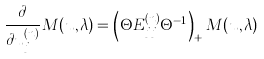Convert formula to latex. <formula><loc_0><loc_0><loc_500><loc_500>\frac { \partial } { \partial u _ { j } ^ { ( n ) } } M ( { u } , \lambda ) = \left ( \Theta E _ { j j } ^ { ( n ) } \Theta ^ { - 1 } \right ) _ { + } M ( { u } , \lambda )</formula> 